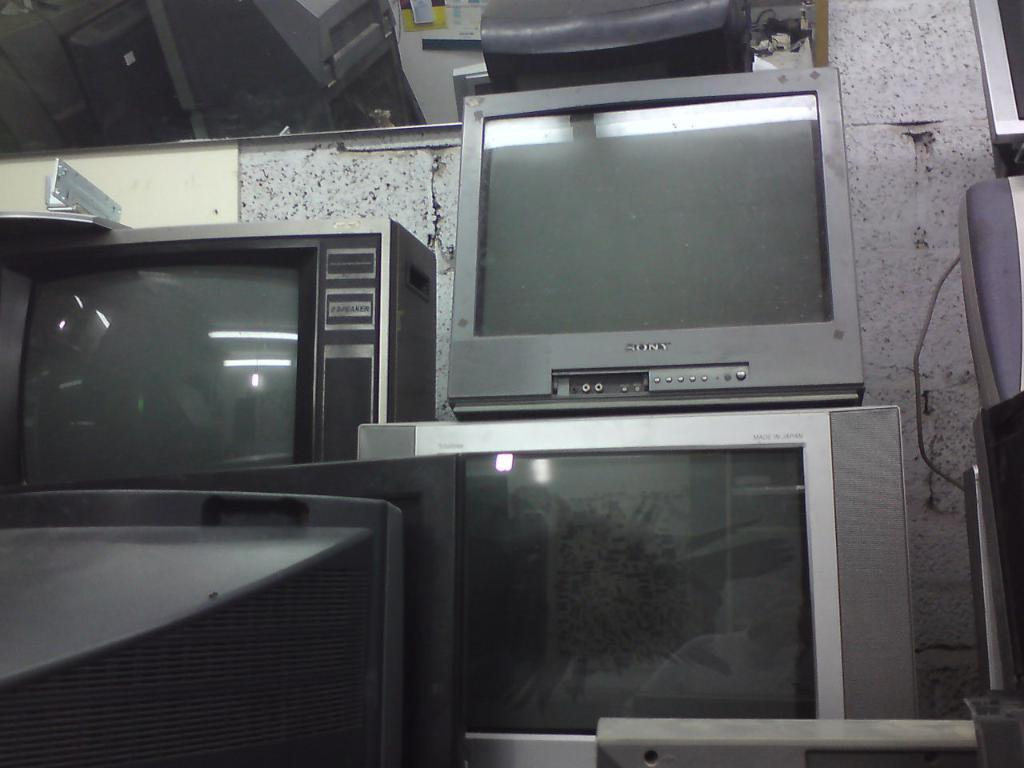<image>
Write a terse but informative summary of the picture. An old Sony television is stacked along wth many other old televisions. 